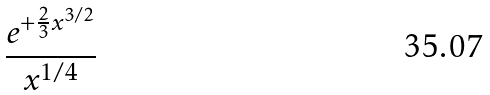Convert formula to latex. <formula><loc_0><loc_0><loc_500><loc_500>\frac { e ^ { + \frac { 2 } { 3 } x ^ { 3 / 2 } } } { x ^ { 1 / 4 } }</formula> 